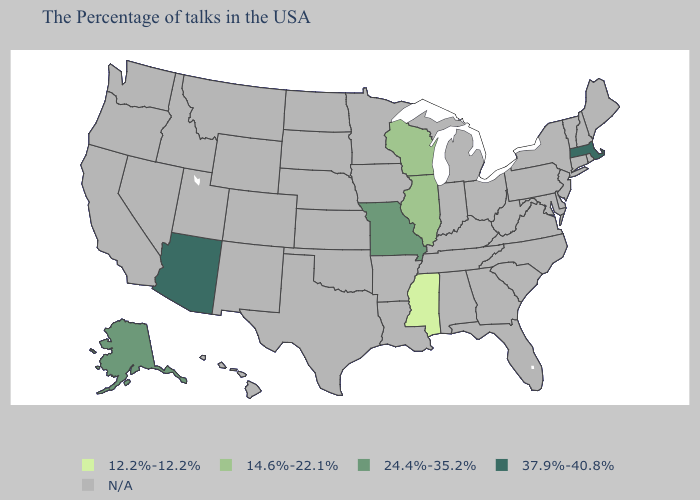Name the states that have a value in the range 12.2%-12.2%?
Concise answer only. Mississippi. Name the states that have a value in the range N/A?
Keep it brief. Maine, Rhode Island, New Hampshire, Vermont, Connecticut, New York, New Jersey, Delaware, Maryland, Pennsylvania, Virginia, North Carolina, South Carolina, West Virginia, Ohio, Florida, Georgia, Michigan, Kentucky, Indiana, Alabama, Tennessee, Louisiana, Arkansas, Minnesota, Iowa, Kansas, Nebraska, Oklahoma, Texas, South Dakota, North Dakota, Wyoming, Colorado, New Mexico, Utah, Montana, Idaho, Nevada, California, Washington, Oregon, Hawaii. Does Missouri have the highest value in the MidWest?
Be succinct. Yes. Name the states that have a value in the range 24.4%-35.2%?
Concise answer only. Missouri, Alaska. Name the states that have a value in the range 14.6%-22.1%?
Concise answer only. Wisconsin, Illinois. What is the highest value in the West ?
Be succinct. 37.9%-40.8%. What is the value of South Dakota?
Keep it brief. N/A. What is the highest value in the South ?
Write a very short answer. 12.2%-12.2%. Does Missouri have the lowest value in the MidWest?
Give a very brief answer. No. What is the value of Utah?
Short answer required. N/A. What is the highest value in states that border New Hampshire?
Short answer required. 37.9%-40.8%. 